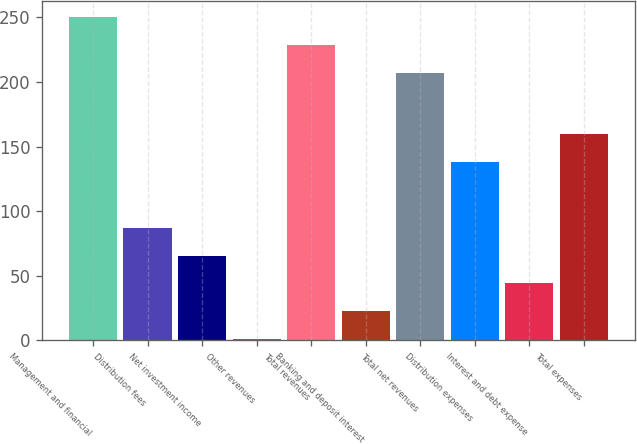Convert chart to OTSL. <chart><loc_0><loc_0><loc_500><loc_500><bar_chart><fcel>Management and financial<fcel>Distribution fees<fcel>Net investment income<fcel>Other revenues<fcel>Total revenues<fcel>Banking and deposit interest<fcel>Total net revenues<fcel>Distribution expenses<fcel>Interest and debt expense<fcel>Total expenses<nl><fcel>250<fcel>87<fcel>65.5<fcel>1<fcel>228.5<fcel>22.5<fcel>207<fcel>138<fcel>44<fcel>159.5<nl></chart> 